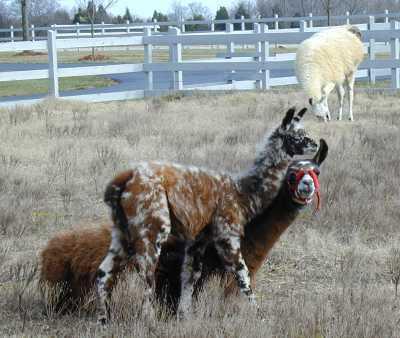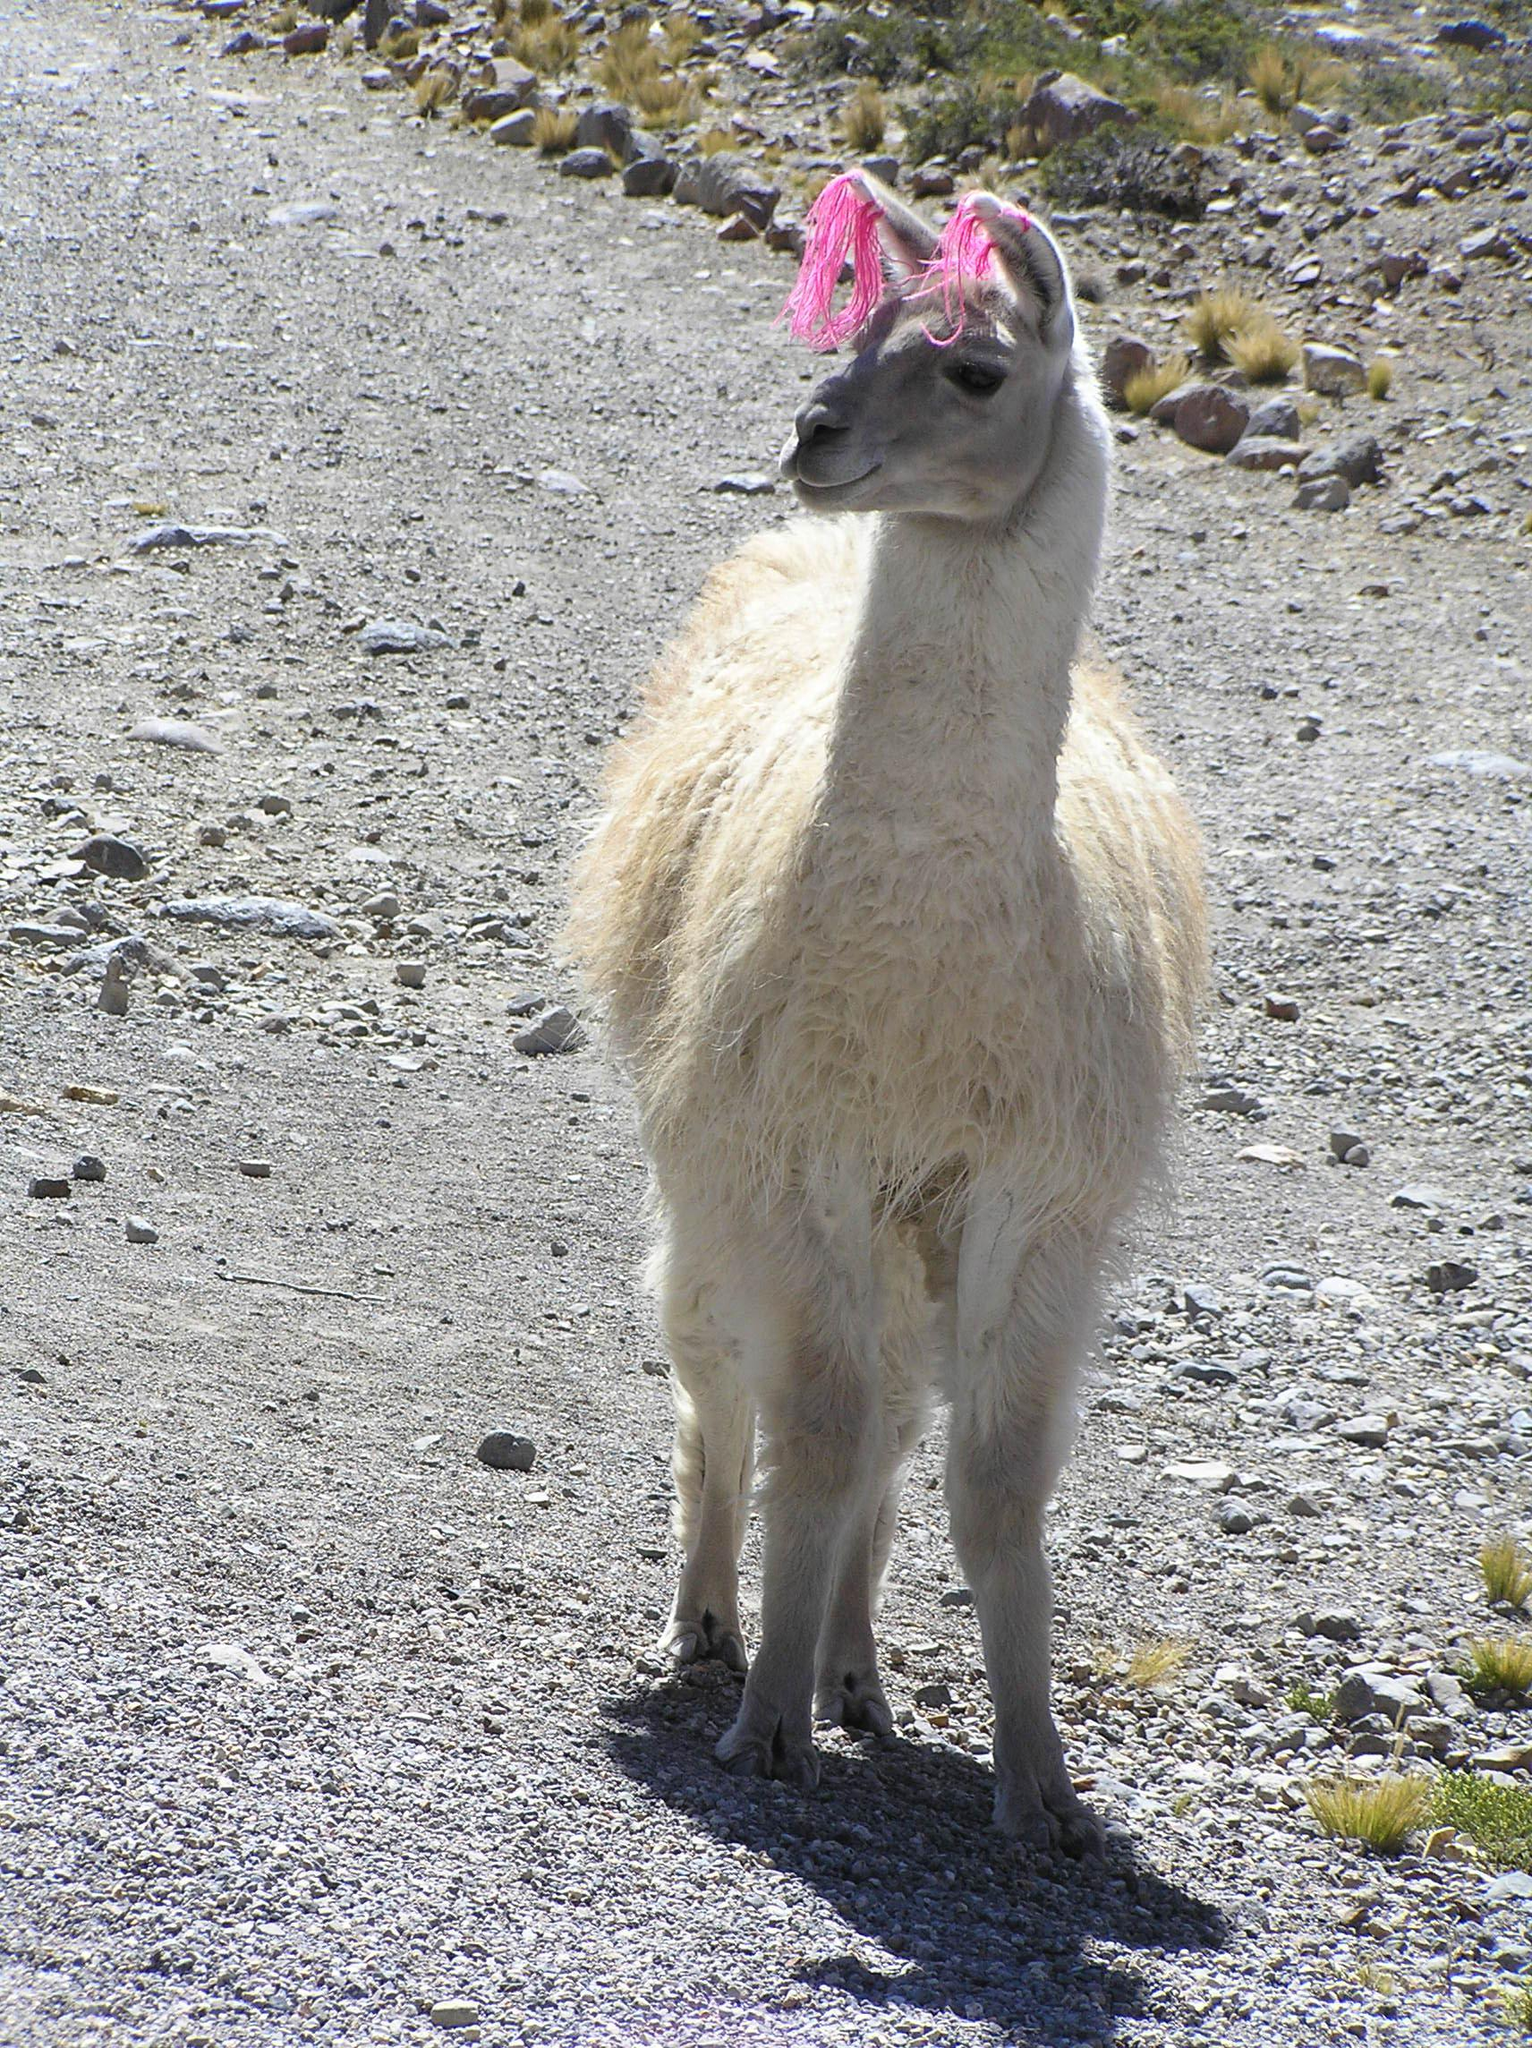The first image is the image on the left, the second image is the image on the right. Considering the images on both sides, is "One image includes a forward-facing standing llama, and the other image includes a reclining llama with another llama alongside it." valid? Answer yes or no. Yes. The first image is the image on the left, the second image is the image on the right. Assess this claim about the two images: "One image shows two alpacas sitting next to each other.". Correct or not? Answer yes or no. No. 